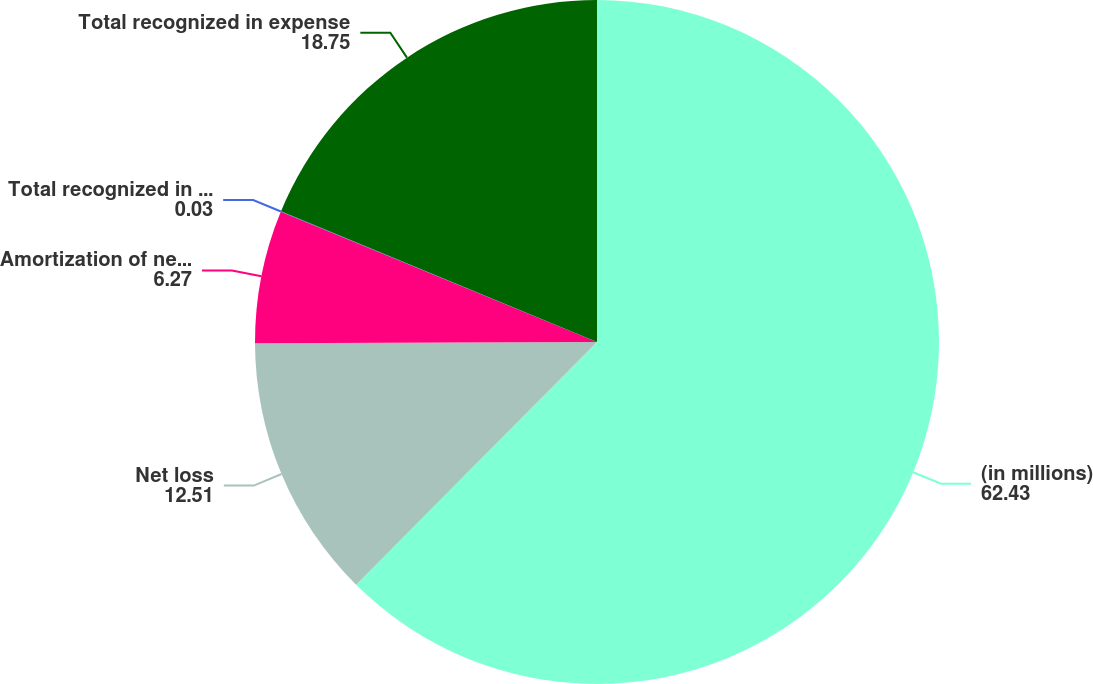Convert chart to OTSL. <chart><loc_0><loc_0><loc_500><loc_500><pie_chart><fcel>(in millions)<fcel>Net loss<fcel>Amortization of net loss<fcel>Total recognized in other<fcel>Total recognized in expense<nl><fcel>62.43%<fcel>12.51%<fcel>6.27%<fcel>0.03%<fcel>18.75%<nl></chart> 